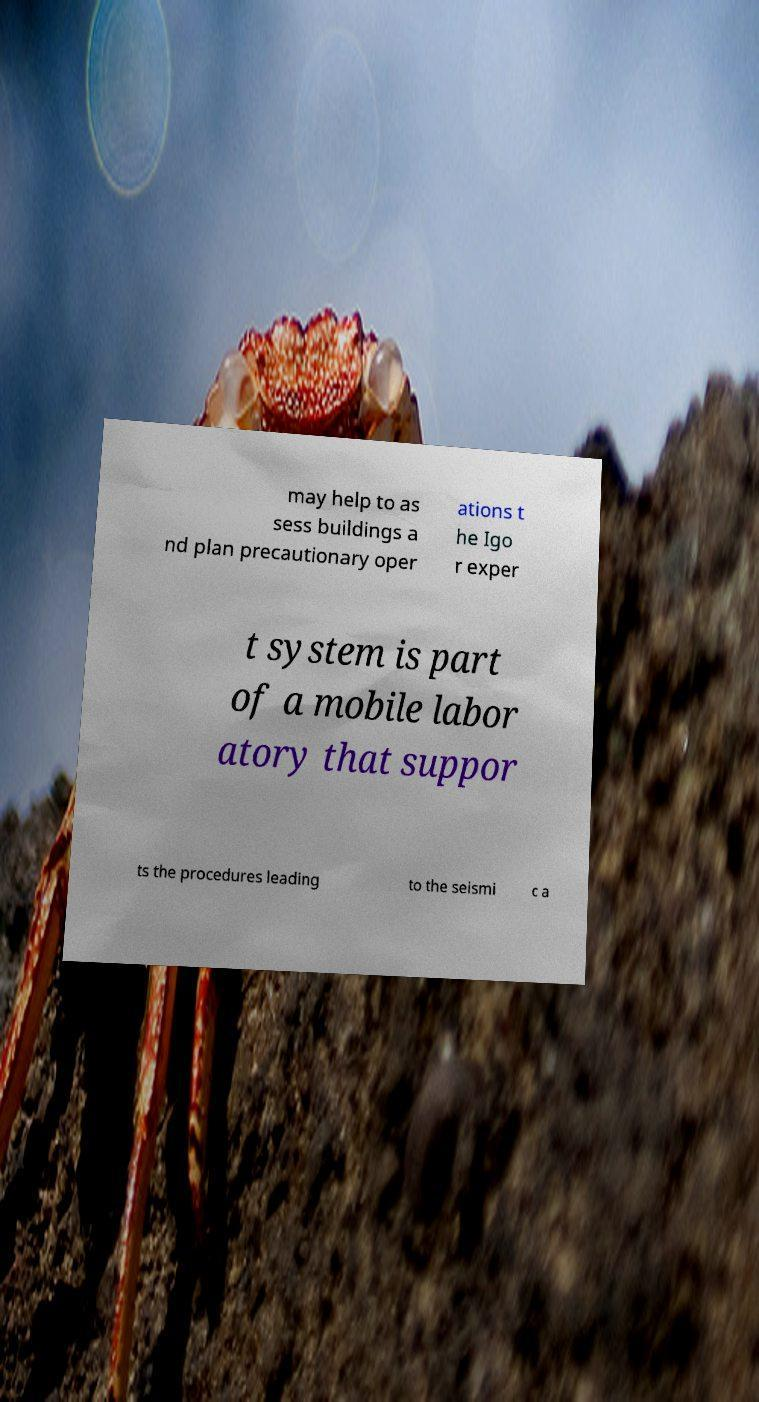For documentation purposes, I need the text within this image transcribed. Could you provide that? may help to as sess buildings a nd plan precautionary oper ations t he Igo r exper t system is part of a mobile labor atory that suppor ts the procedures leading to the seismi c a 